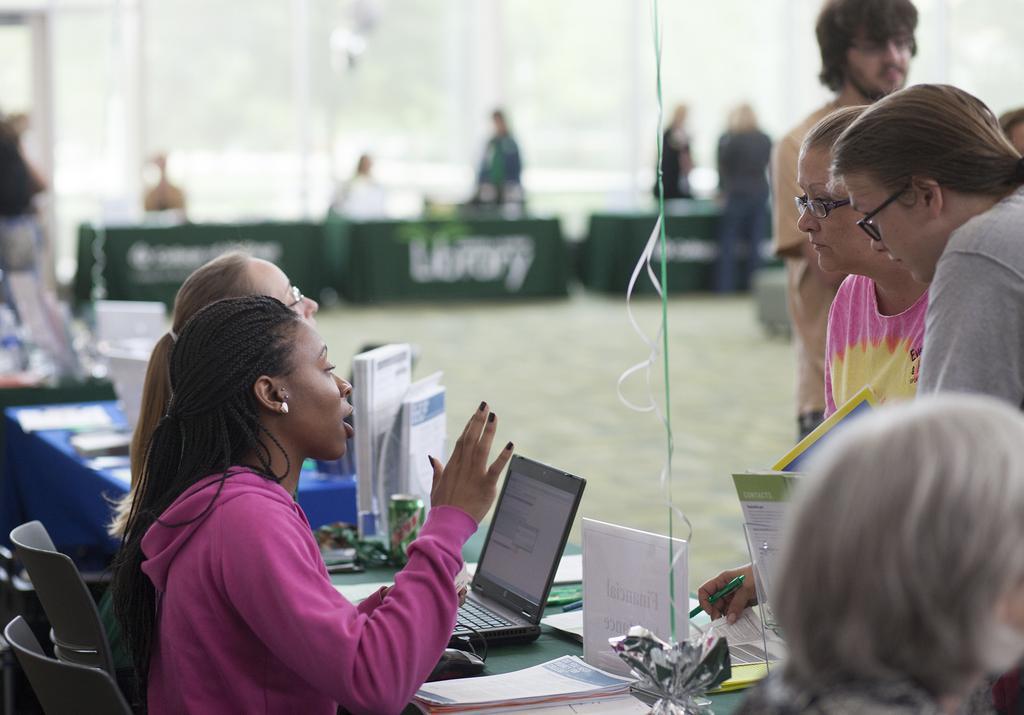In one or two sentences, can you explain what this image depicts? In this image there are two persons sitting on the chairs, and on the table there are papers, books, tin, mouse, laptop, and some objects, and in the background there are group of people standing , a person holding a pen and a paper, boards, stairs, carpet. 